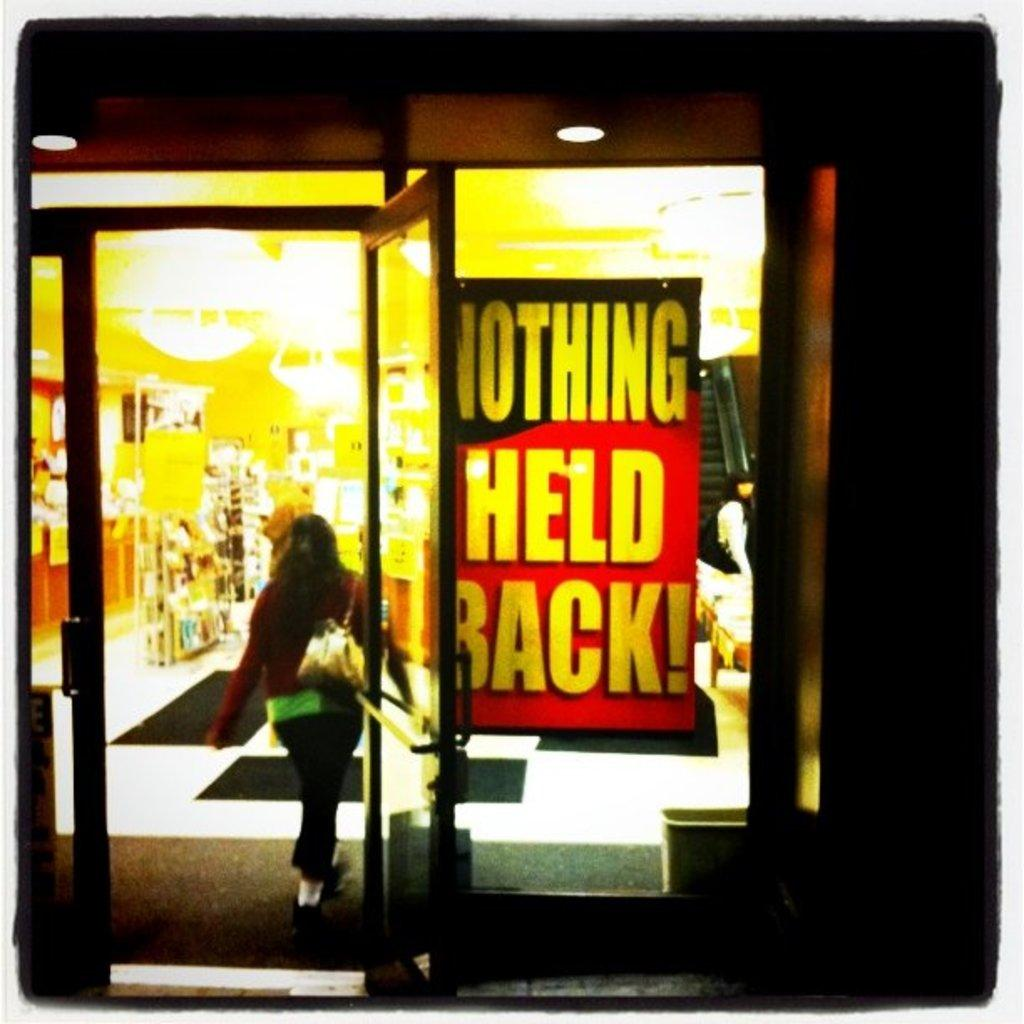Who is present in the image? There is a woman in the image. What can be seen in the background of the image? There are objects in the background of the image. What is visible at the top of the image? There are lights visible at the top of the image. What type of fish can be seen in the picture? There is no fish present in the image; it features a woman and objects in the background. How many copies of the woman are visible in the image? There is only one woman visible in the image, so there are no copies. 